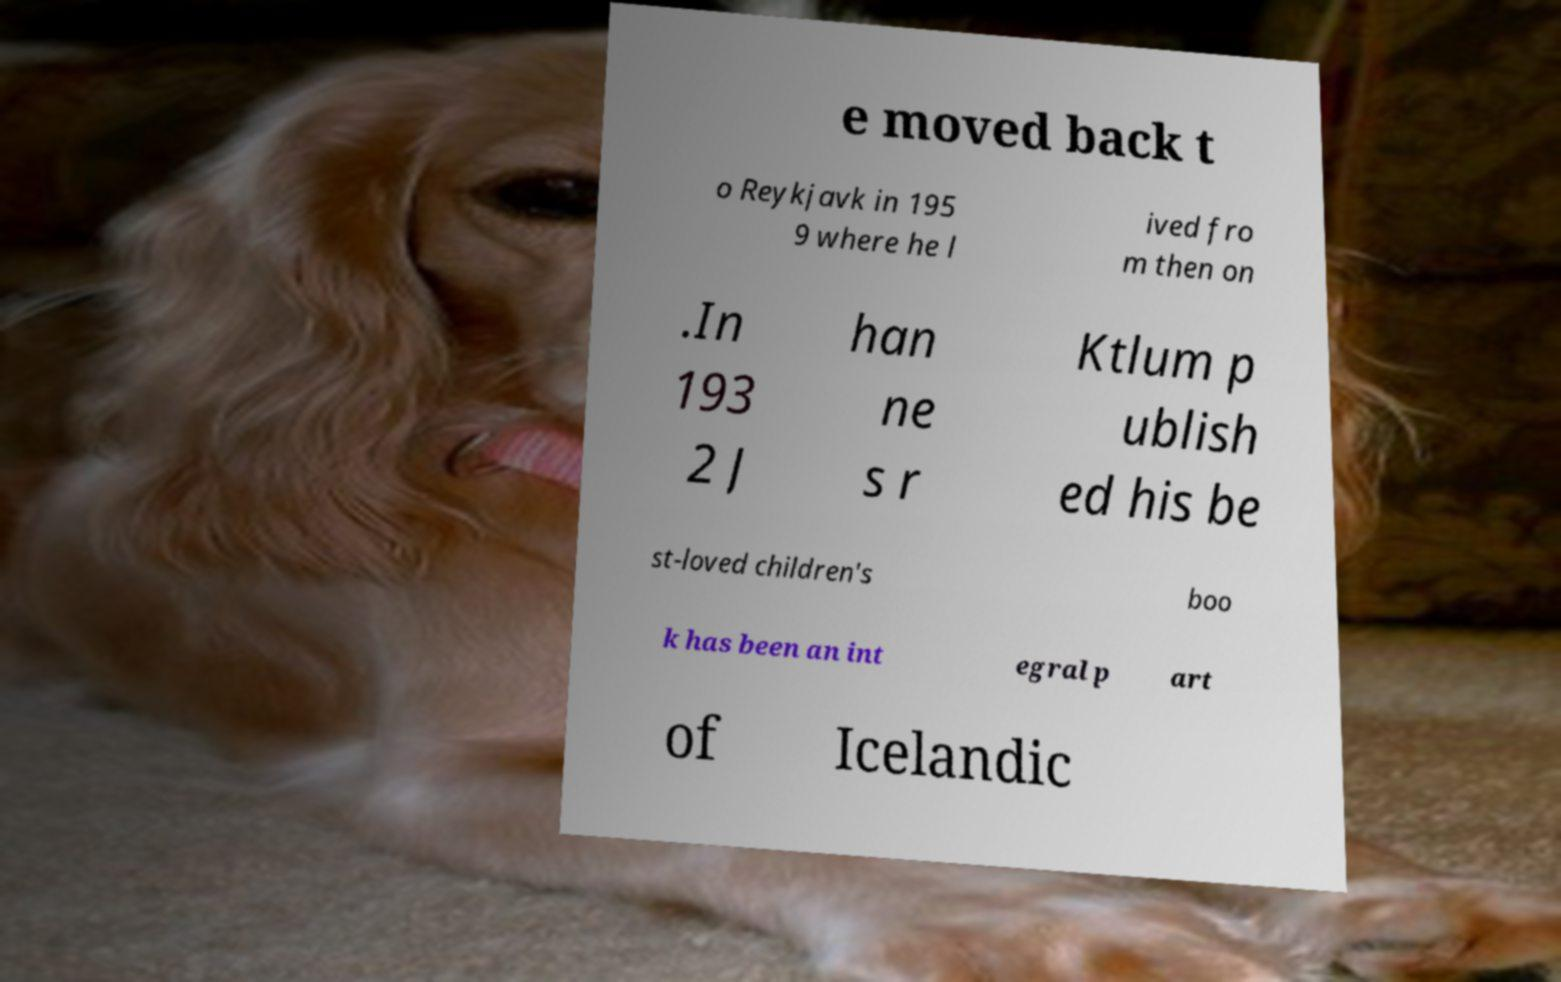Could you assist in decoding the text presented in this image and type it out clearly? e moved back t o Reykjavk in 195 9 where he l ived fro m then on .In 193 2 J han ne s r Ktlum p ublish ed his be st-loved children's boo k has been an int egral p art of Icelandic 